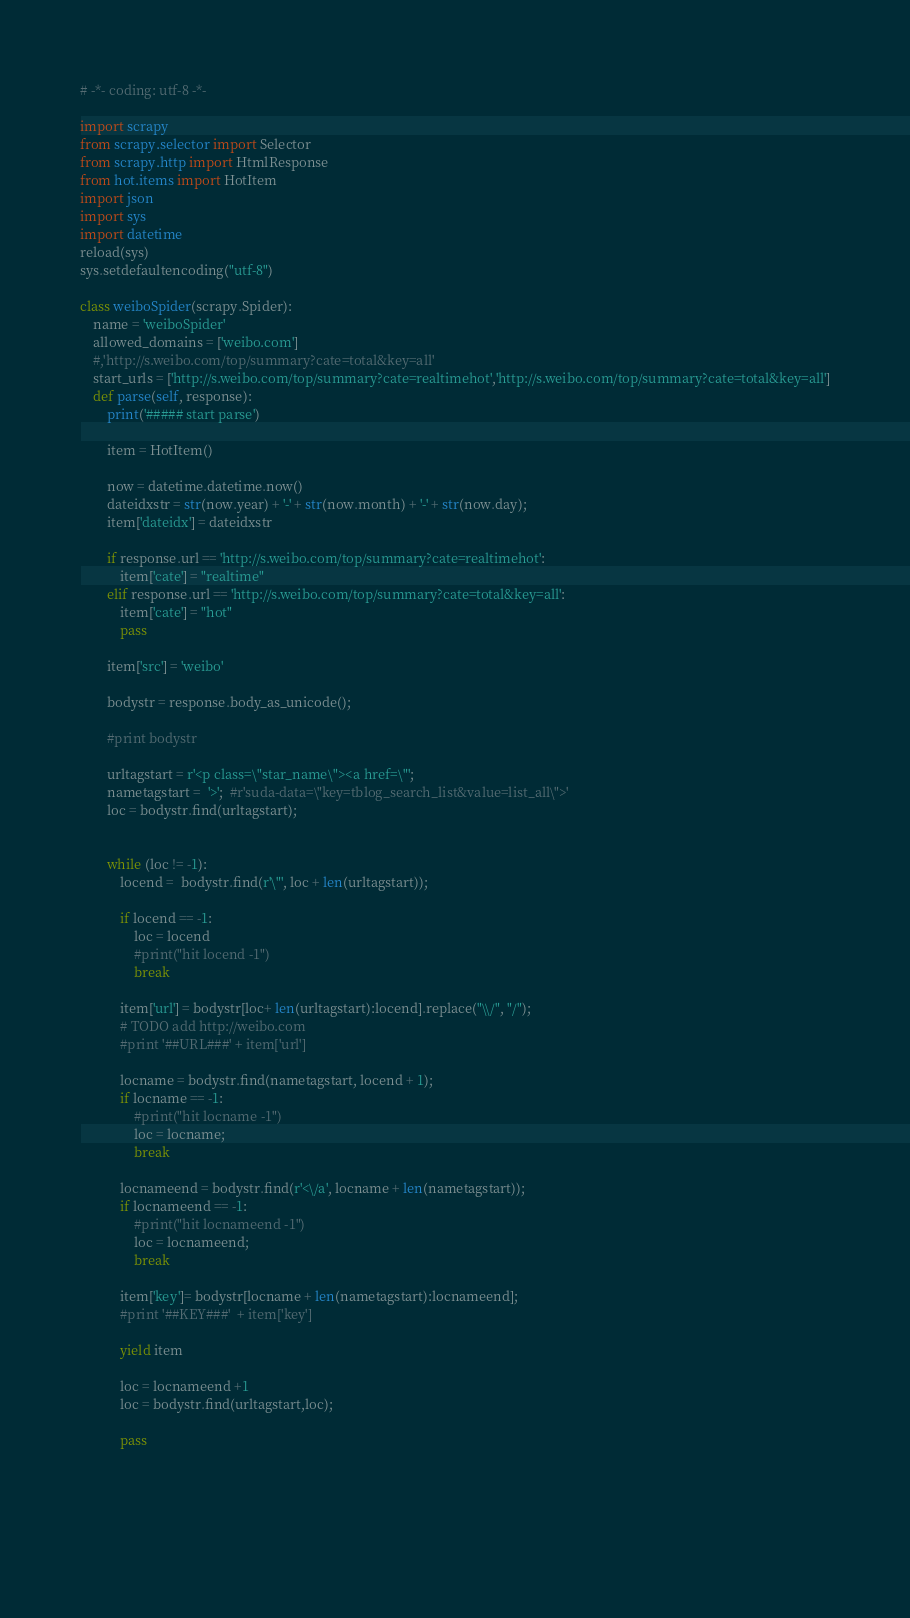<code> <loc_0><loc_0><loc_500><loc_500><_Python_># -*- coding: utf-8 -*-

import scrapy
from scrapy.selector import Selector
from scrapy.http import HtmlResponse
from hot.items import HotItem
import json
import sys
import datetime
reload(sys)
sys.setdefaultencoding("utf-8")

class weiboSpider(scrapy.Spider):
    name = 'weiboSpider'
    allowed_domains = ['weibo.com']
    #,'http://s.weibo.com/top/summary?cate=total&key=all'
    start_urls = ['http://s.weibo.com/top/summary?cate=realtimehot','http://s.weibo.com/top/summary?cate=total&key=all']
    def parse(self, response):
        print('##### start parse')

        item = HotItem()

        now = datetime.datetime.now()
        dateidxstr = str(now.year) + '-' + str(now.month) + '-' + str(now.day);
        item['dateidx'] = dateidxstr

        if response.url == 'http://s.weibo.com/top/summary?cate=realtimehot':
            item['cate'] = "realtime"
        elif response.url == 'http://s.weibo.com/top/summary?cate=total&key=all':
            item['cate'] = "hot"
            pass

        item['src'] = 'weibo'

        bodystr = response.body_as_unicode();

        #print bodystr

        urltagstart = r'<p class=\"star_name\"><a href=\"';
        nametagstart =  '>';  #r'suda-data=\"key=tblog_search_list&value=list_all\">'
        loc = bodystr.find(urltagstart);
   

        while (loc != -1):
            locend =  bodystr.find(r'\"', loc + len(urltagstart));

            if locend == -1:
                loc = locend
                #print("hit locend -1")
                break

            item['url'] = bodystr[loc+ len(urltagstart):locend].replace("\\/", "/");
            # TODO add http://weibo.com
            #print '##URL###' + item['url']

            locname = bodystr.find(nametagstart, locend + 1);
            if locname == -1:
                #print("hit locname -1")
                loc = locname;
                break

            locnameend = bodystr.find(r'<\/a', locname + len(nametagstart));
            if locnameend == -1:
                #print("hit locnameend -1")
                loc = locnameend;
                break

            item['key']= bodystr[locname + len(nametagstart):locnameend];
            #print '##KEY###'  + item['key']

            yield item
            
            loc = locnameend +1
            loc = bodystr.find(urltagstart,loc);
            
            pass




    
</code> 